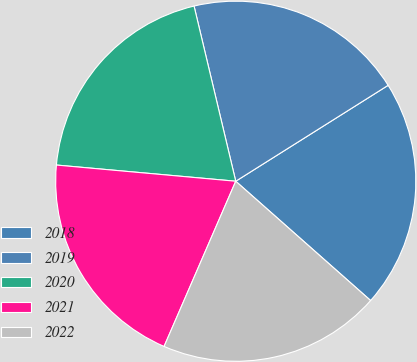Convert chart. <chart><loc_0><loc_0><loc_500><loc_500><pie_chart><fcel>2018<fcel>2019<fcel>2020<fcel>2021<fcel>2022<nl><fcel>20.47%<fcel>19.78%<fcel>19.85%<fcel>19.92%<fcel>19.99%<nl></chart> 